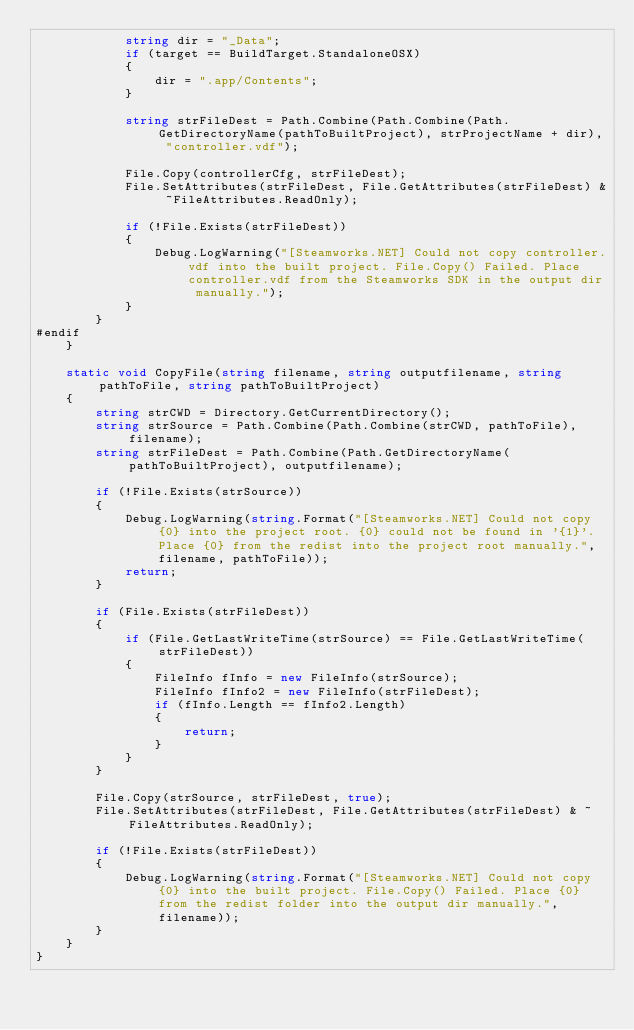Convert code to text. <code><loc_0><loc_0><loc_500><loc_500><_C#_>            string dir = "_Data";
            if (target == BuildTarget.StandaloneOSX)
            {
                dir = ".app/Contents";
            }

            string strFileDest = Path.Combine(Path.Combine(Path.GetDirectoryName(pathToBuiltProject), strProjectName + dir), "controller.vdf");

            File.Copy(controllerCfg, strFileDest);
            File.SetAttributes(strFileDest, File.GetAttributes(strFileDest) & ~FileAttributes.ReadOnly);

            if (!File.Exists(strFileDest))
            {
                Debug.LogWarning("[Steamworks.NET] Could not copy controller.vdf into the built project. File.Copy() Failed. Place controller.vdf from the Steamworks SDK in the output dir manually.");
            }
        }
#endif
    }

    static void CopyFile(string filename, string outputfilename, string pathToFile, string pathToBuiltProject)
    {
        string strCWD = Directory.GetCurrentDirectory();
        string strSource = Path.Combine(Path.Combine(strCWD, pathToFile), filename);
        string strFileDest = Path.Combine(Path.GetDirectoryName(pathToBuiltProject), outputfilename);

        if (!File.Exists(strSource))
        {
            Debug.LogWarning(string.Format("[Steamworks.NET] Could not copy {0} into the project root. {0} could not be found in '{1}'. Place {0} from the redist into the project root manually.", filename, pathToFile));
            return;
        }

        if (File.Exists(strFileDest))
        {
            if (File.GetLastWriteTime(strSource) == File.GetLastWriteTime(strFileDest))
            {
                FileInfo fInfo = new FileInfo(strSource);
                FileInfo fInfo2 = new FileInfo(strFileDest);
                if (fInfo.Length == fInfo2.Length)
                {
                    return;
                }
            }
        }

        File.Copy(strSource, strFileDest, true);
        File.SetAttributes(strFileDest, File.GetAttributes(strFileDest) & ~FileAttributes.ReadOnly);

        if (!File.Exists(strFileDest))
        {
            Debug.LogWarning(string.Format("[Steamworks.NET] Could not copy {0} into the built project. File.Copy() Failed. Place {0} from the redist folder into the output dir manually.", filename));
        }
    }
}
</code> 